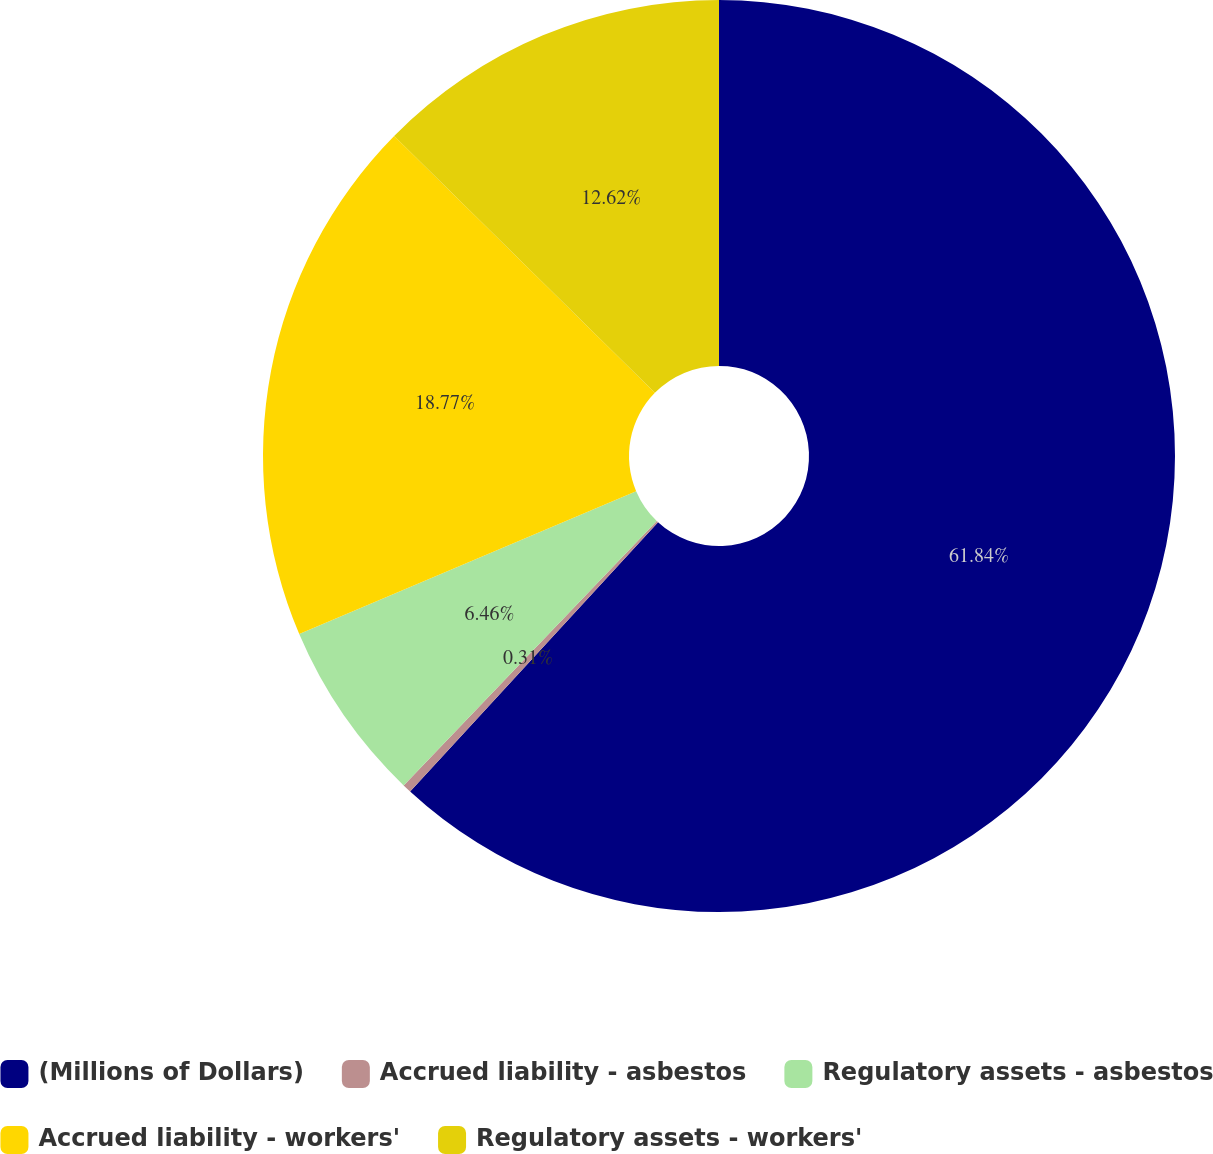Convert chart. <chart><loc_0><loc_0><loc_500><loc_500><pie_chart><fcel>(Millions of Dollars)<fcel>Accrued liability - asbestos<fcel>Regulatory assets - asbestos<fcel>Accrued liability - workers'<fcel>Regulatory assets - workers'<nl><fcel>61.85%<fcel>0.31%<fcel>6.46%<fcel>18.77%<fcel>12.62%<nl></chart> 